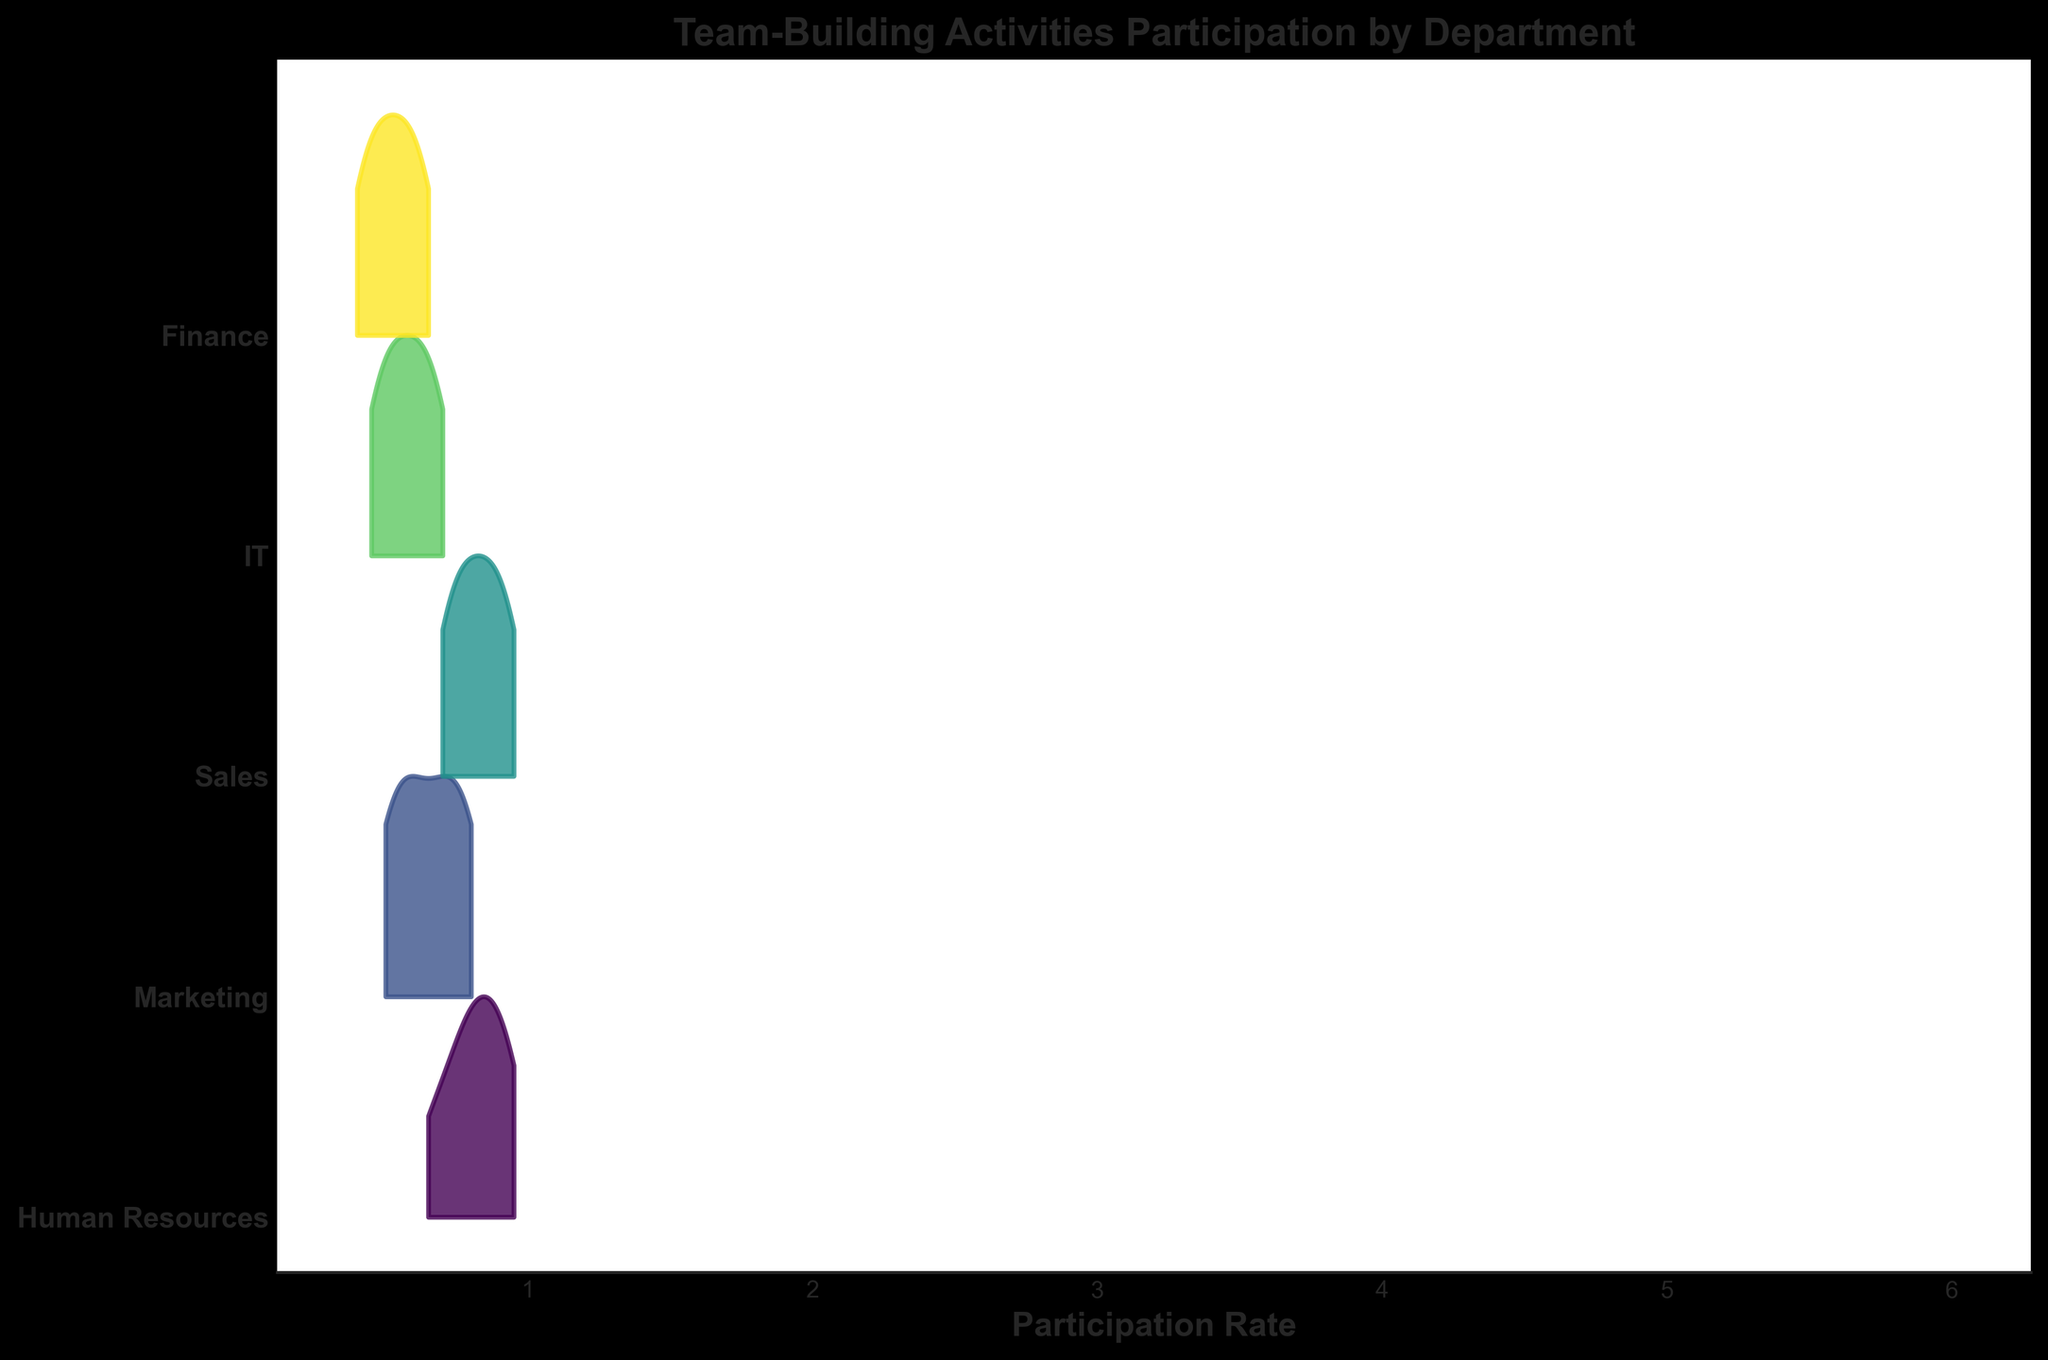What's the title of the plot? The title is typically found at the top of the figure, clearly indicating the content or subject of the visualization. In this case, it reads "Team-Building Activities Participation by Department."
Answer: Team-Building Activities Participation by Department Which department has the highest participation rate in week 6? To find the department with the highest participation rate in week 6, look at the data points representing week 6 and compare their heights. The highest point will be the department with the highest rate, which is Sales at 0.95.
Answer: Sales Which department shows the least participation rate in week 1? By examining the participation rates for week 1 across all departments, the lowest rate can be identified. Finance has the lowest rate at 0.40.
Answer: Finance How does the participation rate of Marketing in week 3 compare to that of IT in week 6? To compare the rates, look at Marketing's rate in week 3 (0.60) and IT's rate in week 6 (0.70). IT's rate is higher.
Answer: IT's rate is higher What is the range of participation rates for Human Resources? The range can be found by subtracting the minimum participation rate from the maximum within the department. Human Resources ranges from 0.65 to 0.95, giving a range of 0.95 - 0.65 = 0.30.
Answer: 0.30 On average, which department had the highest participation rate over the weeks? Calculate the average participation rate for each department by summing the weekly rates and dividing by the number of weeks. Human Resources has the highest average (sum: 0.65+0.75+0.80+0.85+0.90+0.95 = 4.90, average: 4.90 / 6 = 0.817).
Answer: Human Resources What trend do you observe in the Finance department's participation over the weeks? Looking at the participation rates each week for the Finance department, there is a consistent increase week over week from 0.40 to 0.65.
Answer: Increasing trend In which week did the Sales department have the same participation rate as Marketing? By examining the participation rates of both departments across all weeks, it can be observed that in week 5, both had a rate of 0.90.
Answer: Week 5 How do the shapes of the density curves for Sales and IT compare? Comparing the shapes of the density curves for Sales and IT reveals that Sales has a more evenly spread curve while IT has a more narrow and concentrated curve.
Answer: Sales: more spread; IT: narrow 